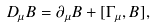<formula> <loc_0><loc_0><loc_500><loc_500>D _ { \mu } B = \partial _ { \mu } B + [ \Gamma _ { \mu } , B ] ,</formula> 